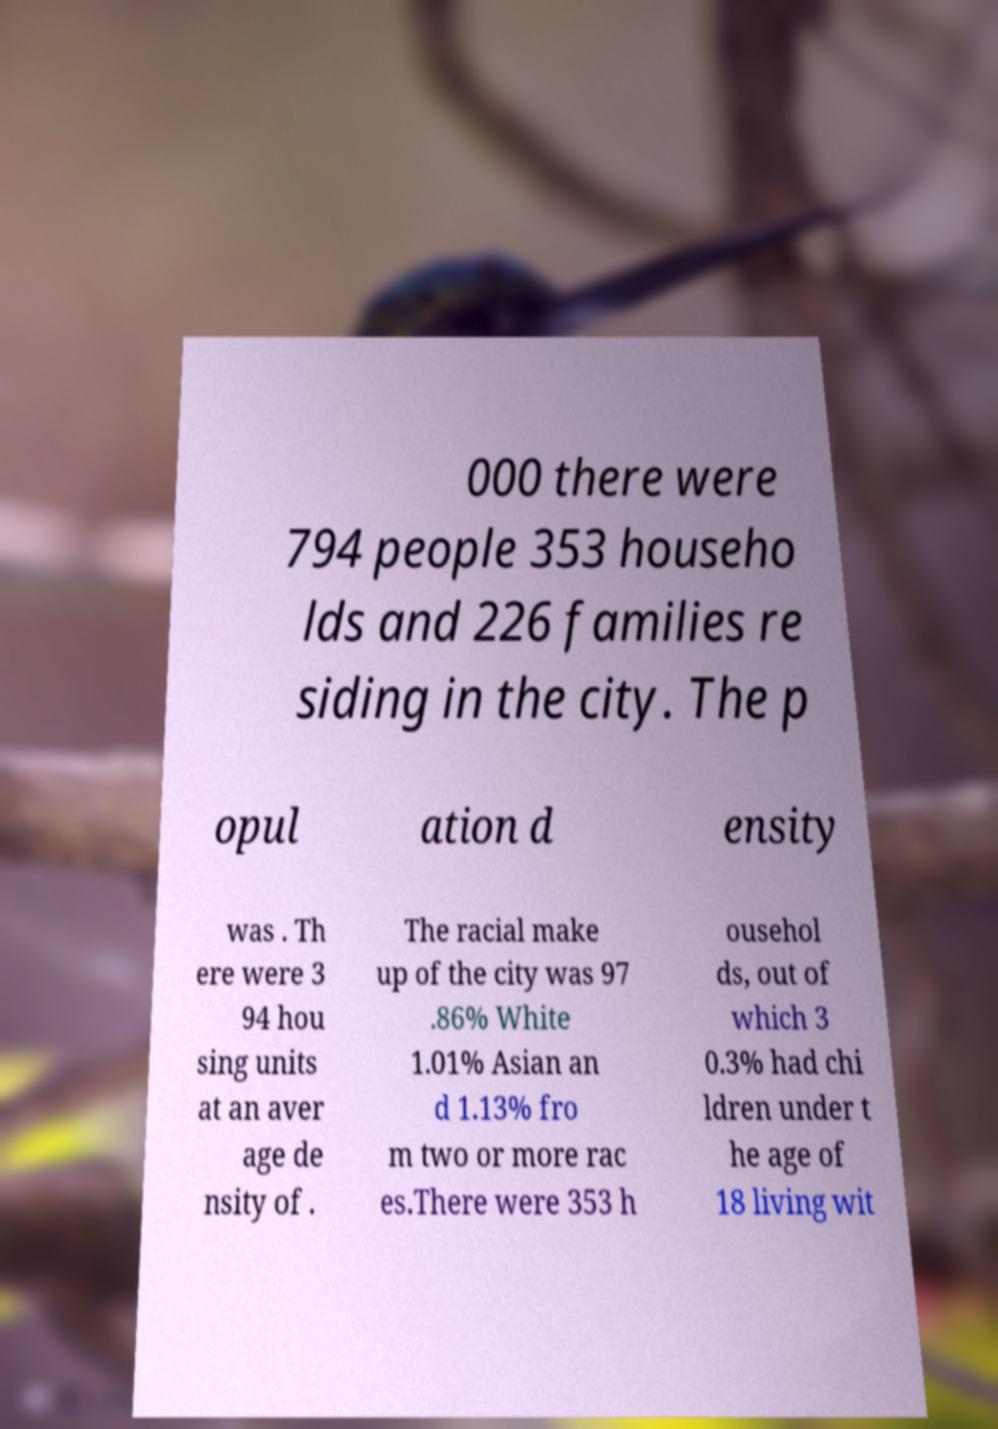Please read and relay the text visible in this image. What does it say? 000 there were 794 people 353 househo lds and 226 families re siding in the city. The p opul ation d ensity was . Th ere were 3 94 hou sing units at an aver age de nsity of . The racial make up of the city was 97 .86% White 1.01% Asian an d 1.13% fro m two or more rac es.There were 353 h ousehol ds, out of which 3 0.3% had chi ldren under t he age of 18 living wit 